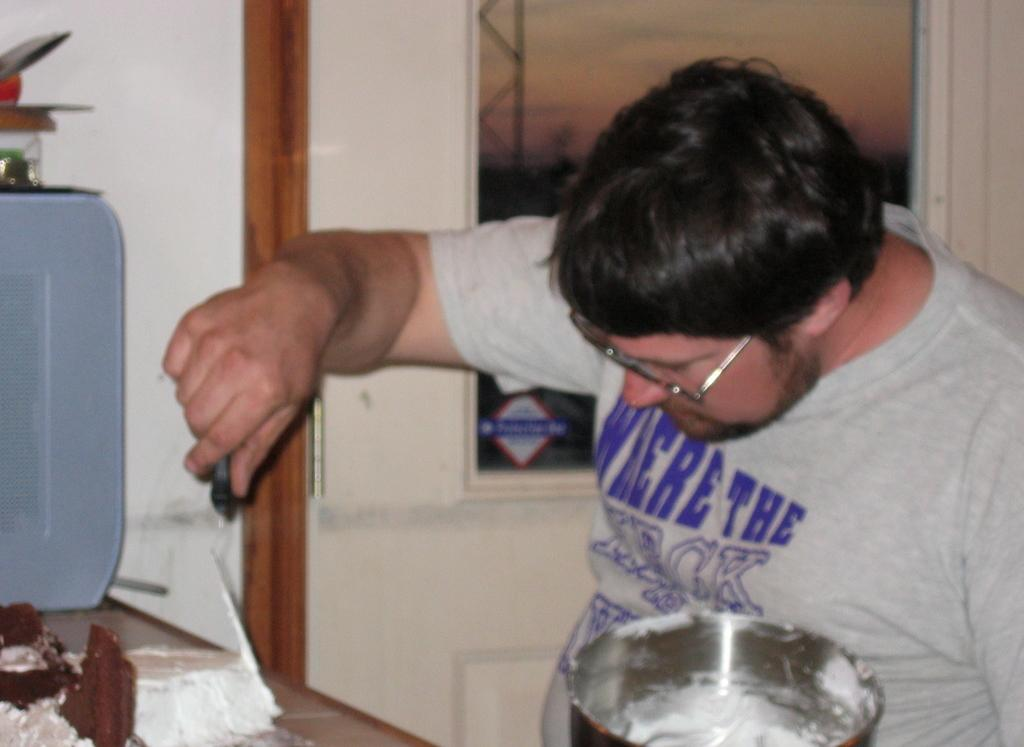<image>
Relay a brief, clear account of the picture shown. A man with glasses and a shirt that says "Where the Heck" 